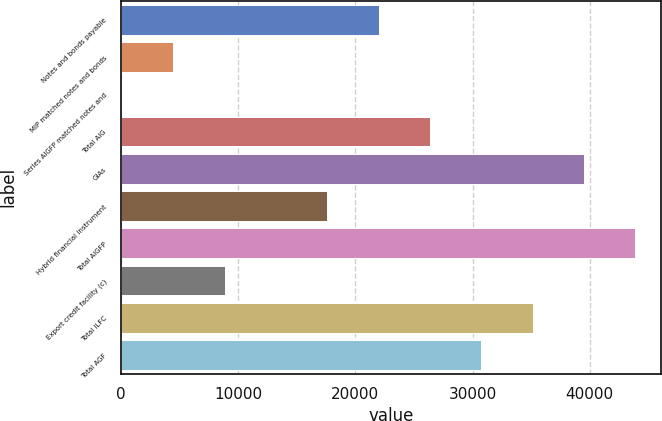Convert chart. <chart><loc_0><loc_0><loc_500><loc_500><bar_chart><fcel>Notes and bonds payable<fcel>MIP matched notes and bonds<fcel>Series AIGFP matched notes and<fcel>Total AIG<fcel>GIAs<fcel>Hybrid financial instrument<fcel>Total AIGFP<fcel>Export credit facility (c)<fcel>Total ILFC<fcel>Total AGF<nl><fcel>21978<fcel>4447.6<fcel>65<fcel>26360.6<fcel>39508.4<fcel>17595.4<fcel>43891<fcel>8830.2<fcel>35125.8<fcel>30743.2<nl></chart> 